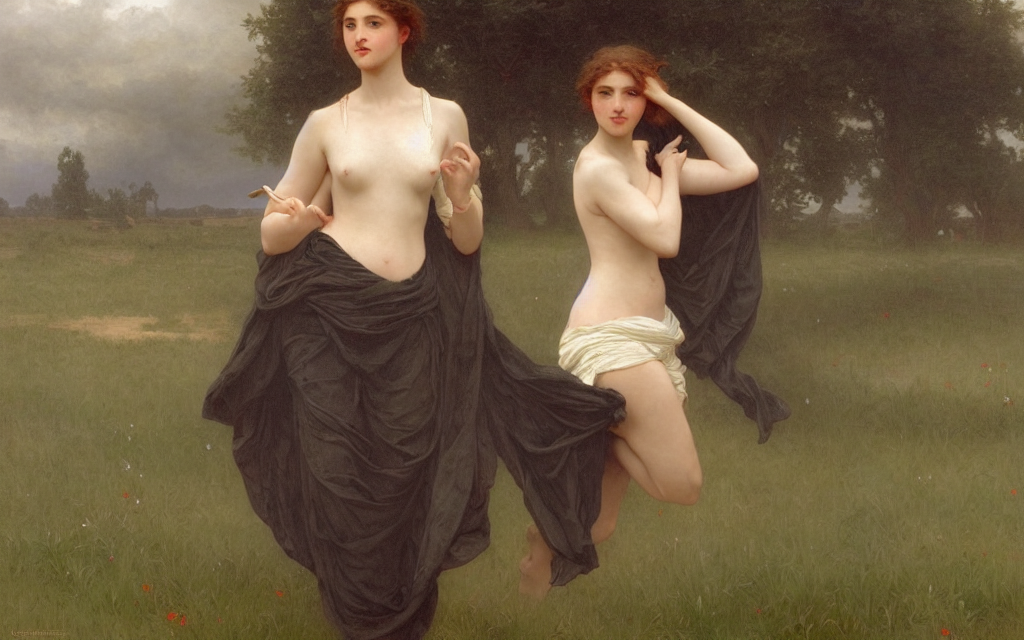What might this scene represent or symbolize? This scene likely symbolizes mythological or allegorical themes, as is common in Neoclassical works. The figures' poise and nudity could represent purity or the celebration of ideal beauty, while the dark draping could suggest a narrative or symbolic significance. 